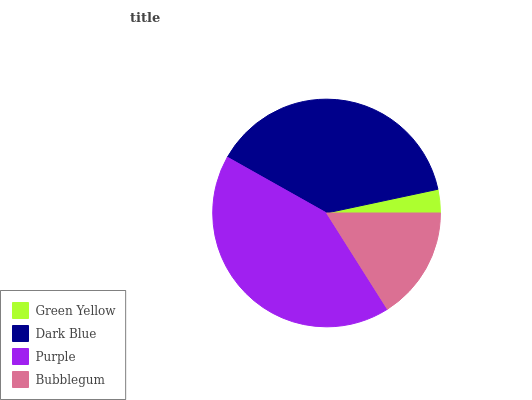Is Green Yellow the minimum?
Answer yes or no. Yes. Is Purple the maximum?
Answer yes or no. Yes. Is Dark Blue the minimum?
Answer yes or no. No. Is Dark Blue the maximum?
Answer yes or no. No. Is Dark Blue greater than Green Yellow?
Answer yes or no. Yes. Is Green Yellow less than Dark Blue?
Answer yes or no. Yes. Is Green Yellow greater than Dark Blue?
Answer yes or no. No. Is Dark Blue less than Green Yellow?
Answer yes or no. No. Is Dark Blue the high median?
Answer yes or no. Yes. Is Bubblegum the low median?
Answer yes or no. Yes. Is Bubblegum the high median?
Answer yes or no. No. Is Green Yellow the low median?
Answer yes or no. No. 